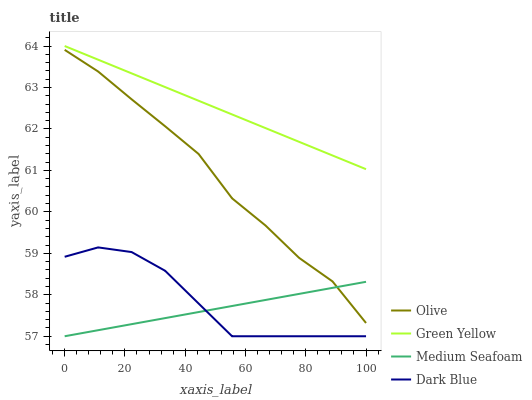Does Medium Seafoam have the minimum area under the curve?
Answer yes or no. Yes. Does Green Yellow have the maximum area under the curve?
Answer yes or no. Yes. Does Dark Blue have the minimum area under the curve?
Answer yes or no. No. Does Dark Blue have the maximum area under the curve?
Answer yes or no. No. Is Green Yellow the smoothest?
Answer yes or no. Yes. Is Dark Blue the roughest?
Answer yes or no. Yes. Is Dark Blue the smoothest?
Answer yes or no. No. Is Green Yellow the roughest?
Answer yes or no. No. Does Green Yellow have the lowest value?
Answer yes or no. No. Does Green Yellow have the highest value?
Answer yes or no. Yes. Does Dark Blue have the highest value?
Answer yes or no. No. Is Dark Blue less than Green Yellow?
Answer yes or no. Yes. Is Green Yellow greater than Dark Blue?
Answer yes or no. Yes. Does Medium Seafoam intersect Dark Blue?
Answer yes or no. Yes. Is Medium Seafoam less than Dark Blue?
Answer yes or no. No. Is Medium Seafoam greater than Dark Blue?
Answer yes or no. No. Does Dark Blue intersect Green Yellow?
Answer yes or no. No. 